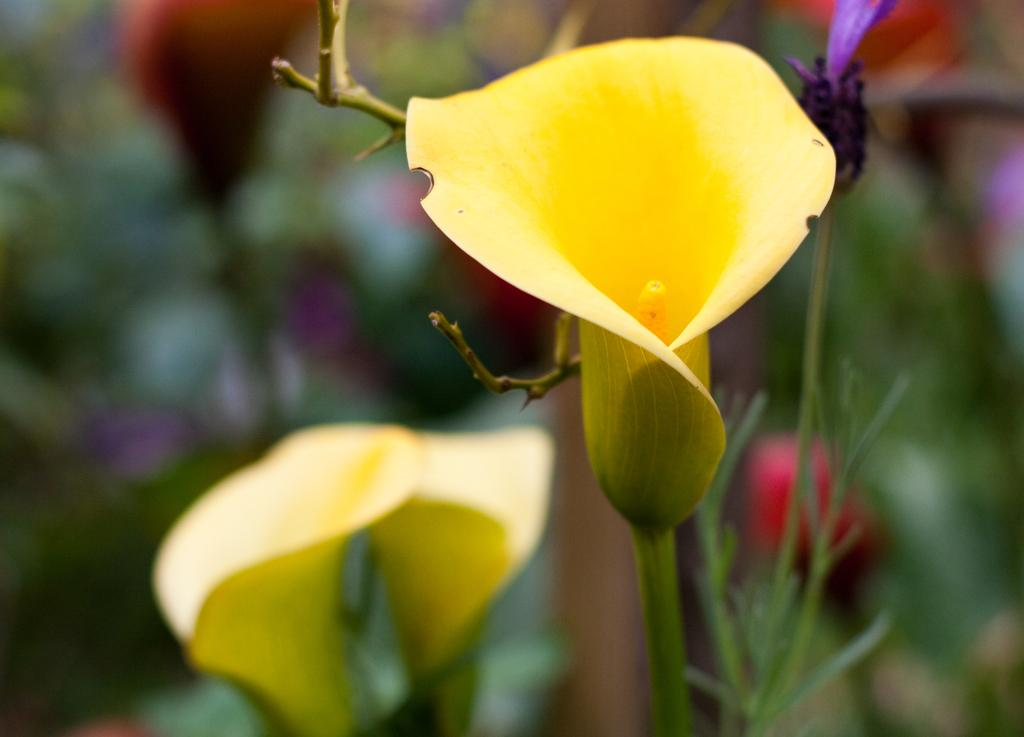What is the main subject of the image? The main subject of the image is yellow color flowers. Can you describe the flowers in the image? The yellow color flowers are located in the center of the image. What can be observed about the background of the image? The background of the image is blurry. What else is visible in the background besides the blurry effect? Flowers and plants are visible in the background. What type of yoke is used to hold the flowers together in the image? There is no yoke present in the image; the flowers are not held together by any visible object. 